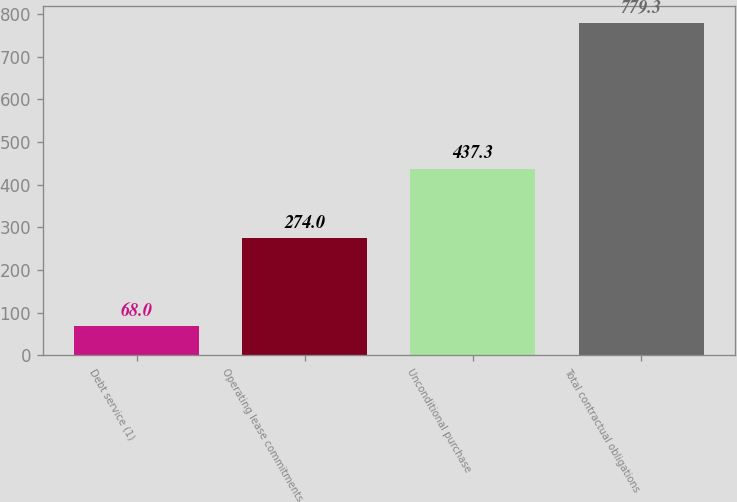Convert chart. <chart><loc_0><loc_0><loc_500><loc_500><bar_chart><fcel>Debt service (1)<fcel>Operating lease commitments<fcel>Unconditional purchase<fcel>Total contractual obligations<nl><fcel>68<fcel>274<fcel>437.3<fcel>779.3<nl></chart> 